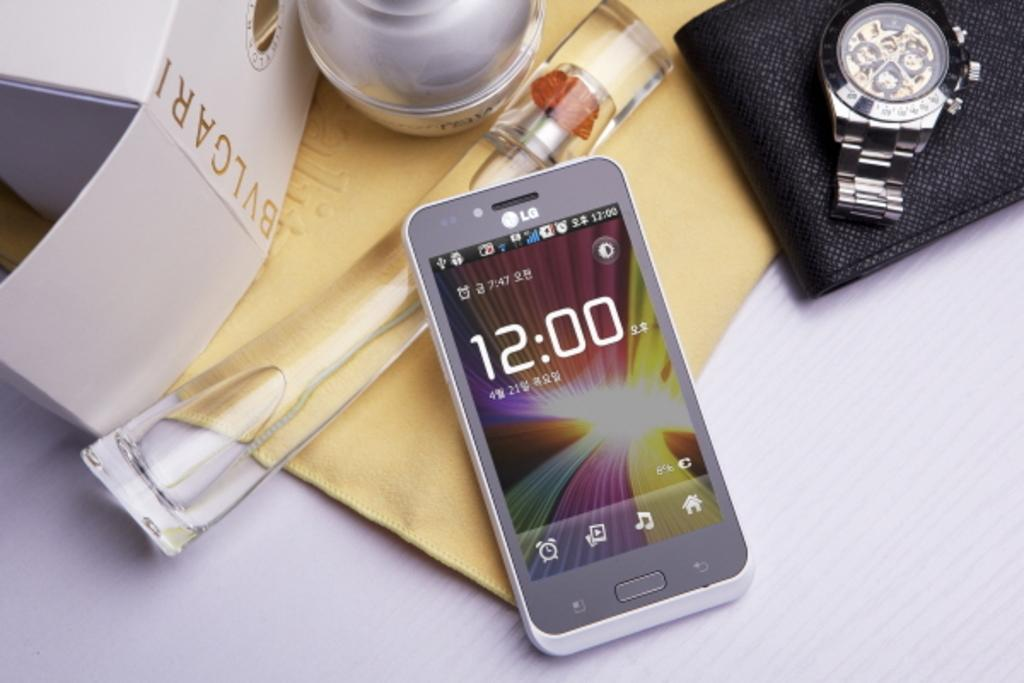Provide a one-sentence caption for the provided image. An LG cell phone laying on a table with an expensive watch and a bottle of BVLGARI perfume. 